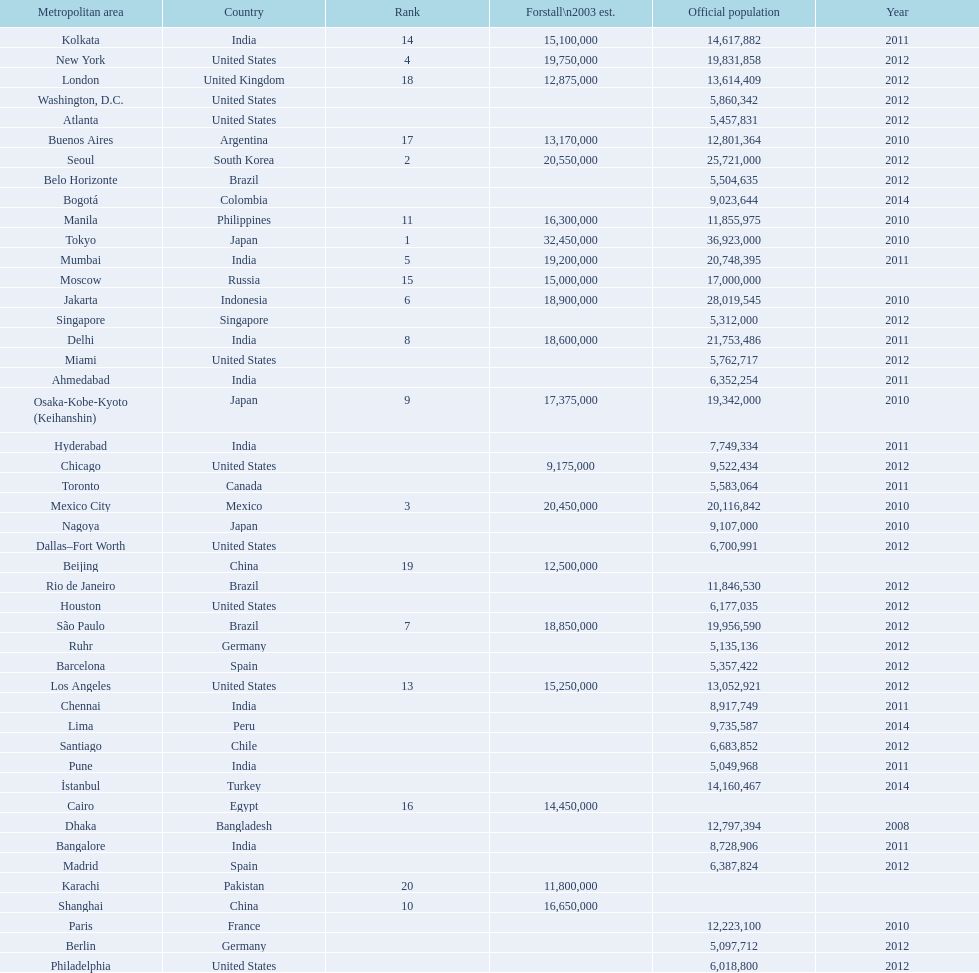Which area is listed above chicago? Chennai. 